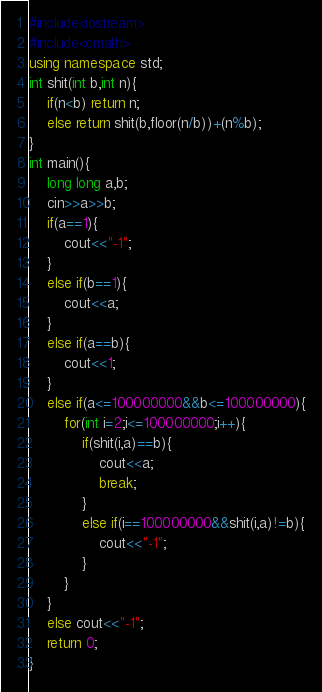<code> <loc_0><loc_0><loc_500><loc_500><_C++_>#include<iostream>
#include<cmath>
using namespace std;
int shit(int b,int n){
	if(n<b) return n;
	else return shit(b,floor(n/b))+(n%b);
}
int main(){
	long long a,b;
    cin>>a>>b;
    if(a==1){
	    cout<<"-1";
    }
	else if(b==1){
		cout<<a;
	} 
	else if(a==b){
		cout<<1;
	}
	else if(a<=100000000&&b<=100000000){
		for(int i=2;i<=100000000;i++){
			if(shit(i,a)==b){
				cout<<a;
				break;
			}
			else if(i==100000000&&shit(i,a)!=b){
				cout<<"-1";
			}
	    }	
	}  
	else cout<<"-1";
	return 0;
}</code> 